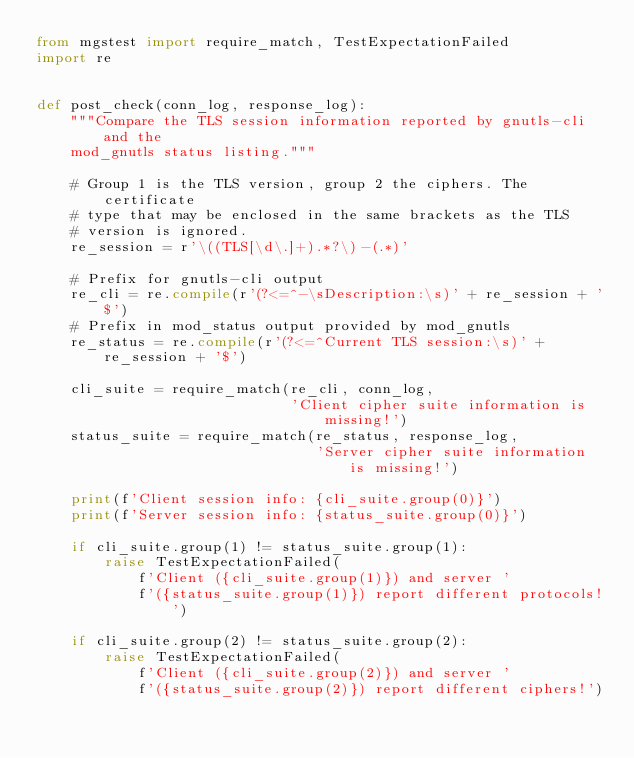<code> <loc_0><loc_0><loc_500><loc_500><_Python_>from mgstest import require_match, TestExpectationFailed
import re


def post_check(conn_log, response_log):
    """Compare the TLS session information reported by gnutls-cli and the
    mod_gnutls status listing."""

    # Group 1 is the TLS version, group 2 the ciphers. The certificate
    # type that may be enclosed in the same brackets as the TLS
    # version is ignored.
    re_session = r'\((TLS[\d\.]+).*?\)-(.*)'

    # Prefix for gnutls-cli output
    re_cli = re.compile(r'(?<=^-\sDescription:\s)' + re_session + '$')
    # Prefix in mod_status output provided by mod_gnutls
    re_status = re.compile(r'(?<=^Current TLS session:\s)' + re_session + '$')

    cli_suite = require_match(re_cli, conn_log,
                              'Client cipher suite information is missing!')
    status_suite = require_match(re_status, response_log,
                                 'Server cipher suite information is missing!')

    print(f'Client session info: {cli_suite.group(0)}')
    print(f'Server session info: {status_suite.group(0)}')

    if cli_suite.group(1) != status_suite.group(1):
        raise TestExpectationFailed(
            f'Client ({cli_suite.group(1)}) and server '
            f'({status_suite.group(1)}) report different protocols!')

    if cli_suite.group(2) != status_suite.group(2):
        raise TestExpectationFailed(
            f'Client ({cli_suite.group(2)}) and server '
            f'({status_suite.group(2)}) report different ciphers!')
</code> 